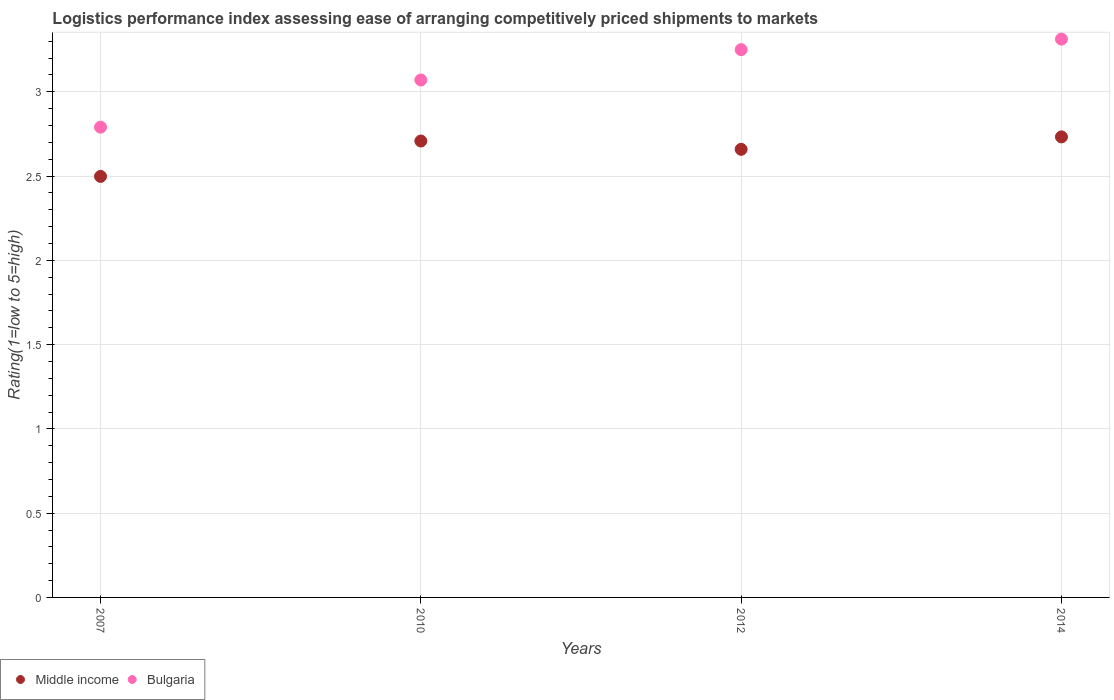What is the Logistic performance index in Middle income in 2010?
Provide a succinct answer. 2.71. Across all years, what is the maximum Logistic performance index in Middle income?
Ensure brevity in your answer.  2.73. Across all years, what is the minimum Logistic performance index in Bulgaria?
Offer a very short reply. 2.79. In which year was the Logistic performance index in Middle income maximum?
Your response must be concise. 2014. What is the total Logistic performance index in Bulgaria in the graph?
Provide a short and direct response. 12.42. What is the difference between the Logistic performance index in Middle income in 2007 and that in 2014?
Keep it short and to the point. -0.23. What is the difference between the Logistic performance index in Bulgaria in 2010 and the Logistic performance index in Middle income in 2007?
Make the answer very short. 0.57. What is the average Logistic performance index in Bulgaria per year?
Ensure brevity in your answer.  3.11. In the year 2012, what is the difference between the Logistic performance index in Bulgaria and Logistic performance index in Middle income?
Your response must be concise. 0.59. In how many years, is the Logistic performance index in Bulgaria greater than 3?
Offer a terse response. 3. What is the ratio of the Logistic performance index in Bulgaria in 2007 to that in 2012?
Make the answer very short. 0.86. What is the difference between the highest and the second highest Logistic performance index in Middle income?
Make the answer very short. 0.02. What is the difference between the highest and the lowest Logistic performance index in Middle income?
Your response must be concise. 0.23. Is the Logistic performance index in Middle income strictly greater than the Logistic performance index in Bulgaria over the years?
Provide a succinct answer. No. How many years are there in the graph?
Your answer should be very brief. 4. Are the values on the major ticks of Y-axis written in scientific E-notation?
Provide a succinct answer. No. Where does the legend appear in the graph?
Provide a succinct answer. Bottom left. What is the title of the graph?
Provide a short and direct response. Logistics performance index assessing ease of arranging competitively priced shipments to markets. What is the label or title of the X-axis?
Your response must be concise. Years. What is the label or title of the Y-axis?
Ensure brevity in your answer.  Rating(1=low to 5=high). What is the Rating(1=low to 5=high) of Middle income in 2007?
Your answer should be compact. 2.5. What is the Rating(1=low to 5=high) of Bulgaria in 2007?
Your response must be concise. 2.79. What is the Rating(1=low to 5=high) in Middle income in 2010?
Your answer should be compact. 2.71. What is the Rating(1=low to 5=high) in Bulgaria in 2010?
Provide a short and direct response. 3.07. What is the Rating(1=low to 5=high) of Middle income in 2012?
Provide a succinct answer. 2.66. What is the Rating(1=low to 5=high) of Bulgaria in 2012?
Provide a succinct answer. 3.25. What is the Rating(1=low to 5=high) in Middle income in 2014?
Your response must be concise. 2.73. What is the Rating(1=low to 5=high) in Bulgaria in 2014?
Your answer should be compact. 3.31. Across all years, what is the maximum Rating(1=low to 5=high) of Middle income?
Offer a terse response. 2.73. Across all years, what is the maximum Rating(1=low to 5=high) in Bulgaria?
Keep it short and to the point. 3.31. Across all years, what is the minimum Rating(1=low to 5=high) of Middle income?
Provide a short and direct response. 2.5. Across all years, what is the minimum Rating(1=low to 5=high) in Bulgaria?
Offer a terse response. 2.79. What is the total Rating(1=low to 5=high) in Middle income in the graph?
Give a very brief answer. 10.6. What is the total Rating(1=low to 5=high) in Bulgaria in the graph?
Provide a succinct answer. 12.42. What is the difference between the Rating(1=low to 5=high) in Middle income in 2007 and that in 2010?
Your response must be concise. -0.21. What is the difference between the Rating(1=low to 5=high) of Bulgaria in 2007 and that in 2010?
Keep it short and to the point. -0.28. What is the difference between the Rating(1=low to 5=high) of Middle income in 2007 and that in 2012?
Offer a very short reply. -0.16. What is the difference between the Rating(1=low to 5=high) of Bulgaria in 2007 and that in 2012?
Offer a terse response. -0.46. What is the difference between the Rating(1=low to 5=high) in Middle income in 2007 and that in 2014?
Offer a terse response. -0.23. What is the difference between the Rating(1=low to 5=high) in Bulgaria in 2007 and that in 2014?
Provide a short and direct response. -0.52. What is the difference between the Rating(1=low to 5=high) of Middle income in 2010 and that in 2012?
Offer a terse response. 0.05. What is the difference between the Rating(1=low to 5=high) of Bulgaria in 2010 and that in 2012?
Your answer should be compact. -0.18. What is the difference between the Rating(1=low to 5=high) of Middle income in 2010 and that in 2014?
Make the answer very short. -0.02. What is the difference between the Rating(1=low to 5=high) in Bulgaria in 2010 and that in 2014?
Make the answer very short. -0.24. What is the difference between the Rating(1=low to 5=high) of Middle income in 2012 and that in 2014?
Provide a succinct answer. -0.07. What is the difference between the Rating(1=low to 5=high) of Bulgaria in 2012 and that in 2014?
Ensure brevity in your answer.  -0.06. What is the difference between the Rating(1=low to 5=high) of Middle income in 2007 and the Rating(1=low to 5=high) of Bulgaria in 2010?
Provide a succinct answer. -0.57. What is the difference between the Rating(1=low to 5=high) of Middle income in 2007 and the Rating(1=low to 5=high) of Bulgaria in 2012?
Your answer should be very brief. -0.75. What is the difference between the Rating(1=low to 5=high) of Middle income in 2007 and the Rating(1=low to 5=high) of Bulgaria in 2014?
Provide a short and direct response. -0.81. What is the difference between the Rating(1=low to 5=high) in Middle income in 2010 and the Rating(1=low to 5=high) in Bulgaria in 2012?
Offer a very short reply. -0.54. What is the difference between the Rating(1=low to 5=high) in Middle income in 2010 and the Rating(1=low to 5=high) in Bulgaria in 2014?
Give a very brief answer. -0.6. What is the difference between the Rating(1=low to 5=high) of Middle income in 2012 and the Rating(1=low to 5=high) of Bulgaria in 2014?
Provide a succinct answer. -0.65. What is the average Rating(1=low to 5=high) in Middle income per year?
Offer a terse response. 2.65. What is the average Rating(1=low to 5=high) of Bulgaria per year?
Offer a very short reply. 3.11. In the year 2007, what is the difference between the Rating(1=low to 5=high) in Middle income and Rating(1=low to 5=high) in Bulgaria?
Your answer should be very brief. -0.29. In the year 2010, what is the difference between the Rating(1=low to 5=high) of Middle income and Rating(1=low to 5=high) of Bulgaria?
Make the answer very short. -0.36. In the year 2012, what is the difference between the Rating(1=low to 5=high) of Middle income and Rating(1=low to 5=high) of Bulgaria?
Ensure brevity in your answer.  -0.59. In the year 2014, what is the difference between the Rating(1=low to 5=high) of Middle income and Rating(1=low to 5=high) of Bulgaria?
Provide a short and direct response. -0.58. What is the ratio of the Rating(1=low to 5=high) of Middle income in 2007 to that in 2010?
Make the answer very short. 0.92. What is the ratio of the Rating(1=low to 5=high) in Bulgaria in 2007 to that in 2010?
Your response must be concise. 0.91. What is the ratio of the Rating(1=low to 5=high) of Middle income in 2007 to that in 2012?
Your response must be concise. 0.94. What is the ratio of the Rating(1=low to 5=high) in Bulgaria in 2007 to that in 2012?
Your answer should be very brief. 0.86. What is the ratio of the Rating(1=low to 5=high) of Middle income in 2007 to that in 2014?
Keep it short and to the point. 0.91. What is the ratio of the Rating(1=low to 5=high) in Bulgaria in 2007 to that in 2014?
Make the answer very short. 0.84. What is the ratio of the Rating(1=low to 5=high) in Middle income in 2010 to that in 2012?
Offer a very short reply. 1.02. What is the ratio of the Rating(1=low to 5=high) in Bulgaria in 2010 to that in 2012?
Your response must be concise. 0.94. What is the ratio of the Rating(1=low to 5=high) in Middle income in 2010 to that in 2014?
Give a very brief answer. 0.99. What is the ratio of the Rating(1=low to 5=high) of Bulgaria in 2010 to that in 2014?
Keep it short and to the point. 0.93. What is the ratio of the Rating(1=low to 5=high) in Middle income in 2012 to that in 2014?
Keep it short and to the point. 0.97. What is the ratio of the Rating(1=low to 5=high) in Bulgaria in 2012 to that in 2014?
Give a very brief answer. 0.98. What is the difference between the highest and the second highest Rating(1=low to 5=high) of Middle income?
Make the answer very short. 0.02. What is the difference between the highest and the second highest Rating(1=low to 5=high) of Bulgaria?
Your answer should be compact. 0.06. What is the difference between the highest and the lowest Rating(1=low to 5=high) in Middle income?
Your answer should be compact. 0.23. What is the difference between the highest and the lowest Rating(1=low to 5=high) in Bulgaria?
Keep it short and to the point. 0.52. 